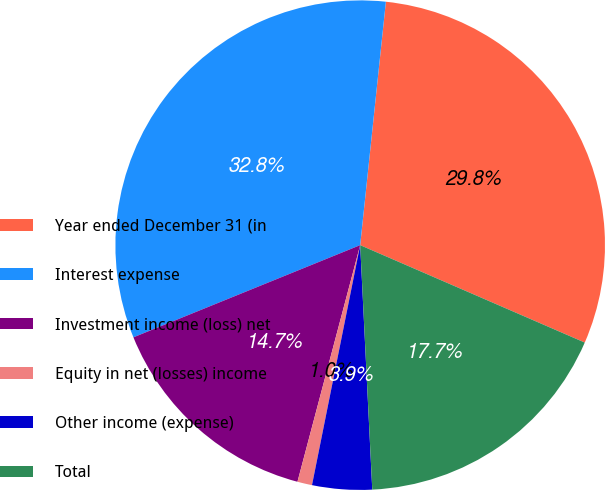Convert chart to OTSL. <chart><loc_0><loc_0><loc_500><loc_500><pie_chart><fcel>Year ended December 31 (in<fcel>Interest expense<fcel>Investment income (loss) net<fcel>Equity in net (losses) income<fcel>Other income (expense)<fcel>Total<nl><fcel>29.84%<fcel>32.82%<fcel>14.73%<fcel>0.97%<fcel>3.94%<fcel>17.7%<nl></chart> 